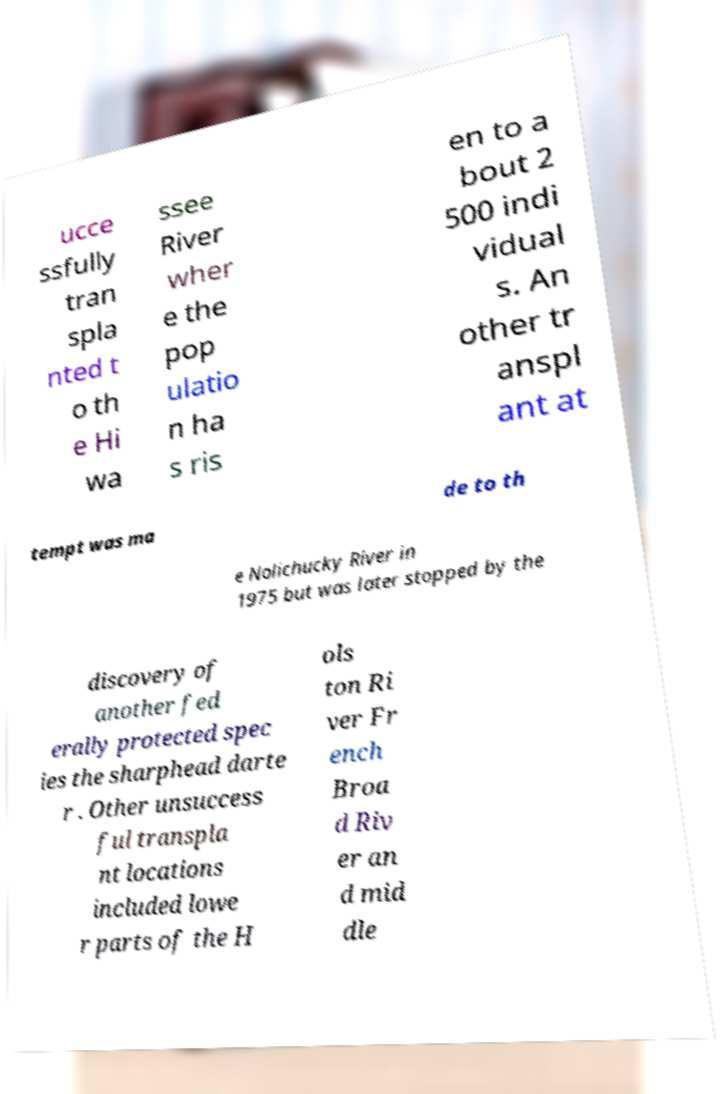Can you accurately transcribe the text from the provided image for me? ucce ssfully tran spla nted t o th e Hi wa ssee River wher e the pop ulatio n ha s ris en to a bout 2 500 indi vidual s. An other tr anspl ant at tempt was ma de to th e Nolichucky River in 1975 but was later stopped by the discovery of another fed erally protected spec ies the sharphead darte r . Other unsuccess ful transpla nt locations included lowe r parts of the H ols ton Ri ver Fr ench Broa d Riv er an d mid dle 